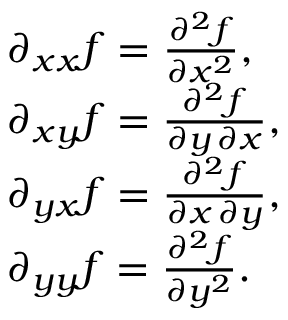Convert formula to latex. <formula><loc_0><loc_0><loc_500><loc_500>{ \begin{array} { r l } & { \partial _ { x x } f = { \frac { \partial ^ { 2 } f } { \partial x ^ { 2 } } } , } \\ & { \partial _ { x y } f = { \frac { \partial ^ { 2 } f } { \partial y \, \partial x } } , } \\ & { \partial _ { y x } f = { \frac { \partial ^ { 2 } f } { \partial x \, \partial y } } , } \\ & { \partial _ { y y } f = { \frac { \partial ^ { 2 } f } { \partial y ^ { 2 } } } . } \end{array} }</formula> 